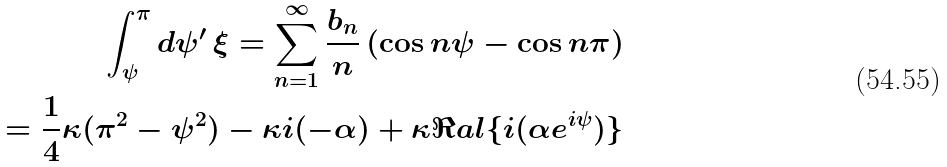Convert formula to latex. <formula><loc_0><loc_0><loc_500><loc_500>\int _ { \psi } ^ { \pi } d \psi ^ { \prime } \, \xi = \sum _ { n = 1 } ^ { \infty } \frac { b _ { n } } { n } \, ( \cos n \psi - \cos n \pi ) \\ = \frac { 1 } { 4 } \kappa ( \pi ^ { 2 } - \psi ^ { 2 } ) - \kappa \L i ( - \alpha ) + \kappa \Re a l \{ \L i ( \alpha e ^ { i \psi } ) \}</formula> 